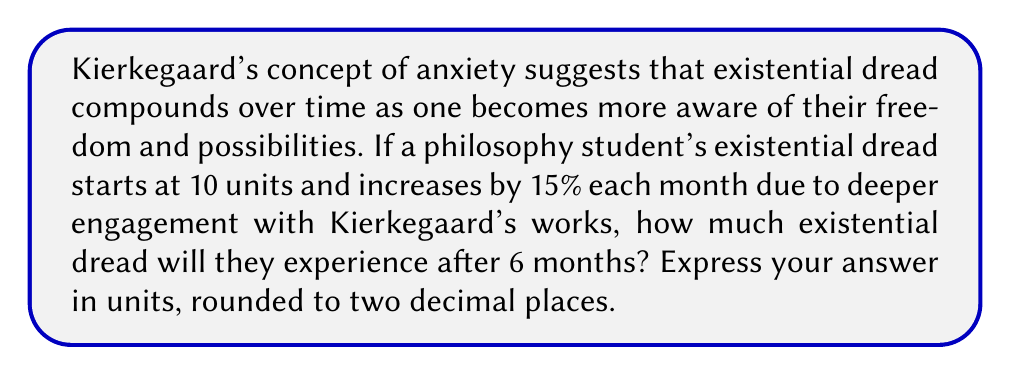Help me with this question. Let's approach this problem using the compound interest formula:

$$A = P(1 + r)^t$$

Where:
$A$ = Final amount
$P$ = Principal (initial amount)
$r$ = Rate of increase (as a decimal)
$t$ = Time periods

Given:
$P = 10$ units (initial existential dread)
$r = 0.15$ (15% increase per month)
$t = 6$ months

Step 1: Plug the values into the formula
$$A = 10(1 + 0.15)^6$$

Step 2: Simplify the expression inside the parentheses
$$A = 10(1.15)^6$$

Step 3: Calculate the exponent
$$A = 10 * 2.3131827$$

Step 4: Multiply
$$A = 23.131827$$

Step 5: Round to two decimal places
$$A ≈ 23.13$$

Therefore, after 6 months, the student will experience approximately 23.13 units of existential dread.
Answer: 23.13 units 